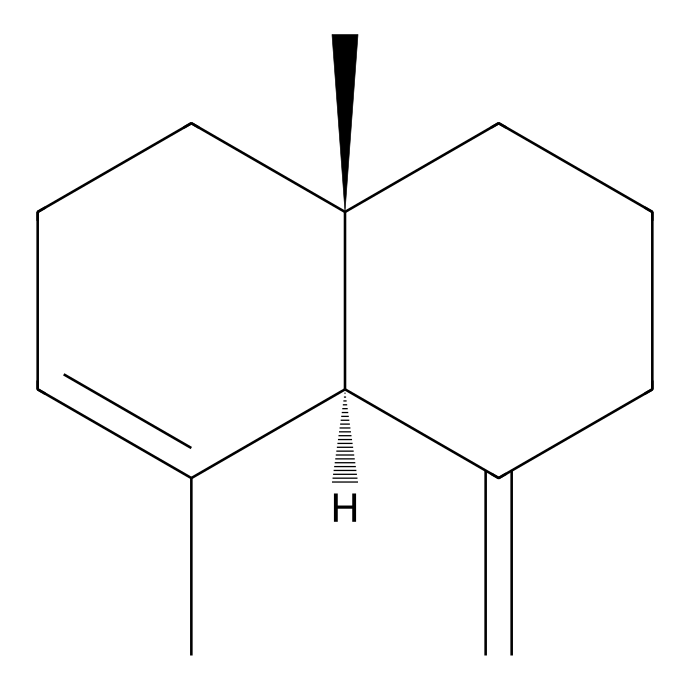What is the total number of carbon atoms in β-caryophyllene? The SMILES representation indicates that there are a total of 15 carbon atoms. Each "C" represents a carbon atom, and when counting them, you find 15 in total.
Answer: 15 How many double bonds are present in this compound? By analyzing the structure depicted in the SMILES, there is one double bond (C=C) present in the molecule. In the structure, you can see that it shows a double bond connection between the two carbon atoms.
Answer: 1 What type of terpene is β-caryophyllene classified as? β-caryophyllene is classified as a bicyclic sesquiterpene because it consists of a structure with 15 carbon atoms and 3 cycles, which signifies its classification.
Answer: bicyclic sesquiterpene How many rings are present in the structure of β-caryophyllene? By examining the structure, you can observe that there are two distinct rings within the compound. The structure forms two cyclic arrangements of carbon atoms.
Answer: 2 What is the functional group present in β-caryophyllene? β-caryophyllene contains an alkene functional group due to the presence of a carbon-carbon double bond (C=C) in its structure.
Answer: alkene 